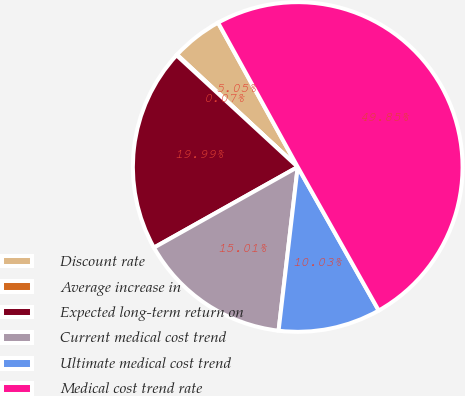Convert chart to OTSL. <chart><loc_0><loc_0><loc_500><loc_500><pie_chart><fcel>Discount rate<fcel>Average increase in<fcel>Expected long-term return on<fcel>Current medical cost trend<fcel>Ultimate medical cost trend<fcel>Medical cost trend rate<nl><fcel>5.05%<fcel>0.07%<fcel>19.99%<fcel>15.01%<fcel>10.03%<fcel>49.85%<nl></chart> 